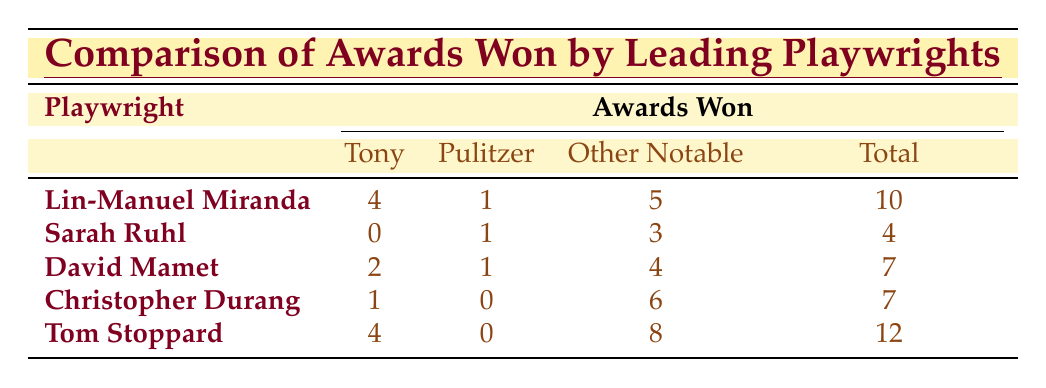What's the total number of awards won by Lin-Manuel Miranda? Lin-Manuel Miranda has won 4 Tony Awards, 1 Pulitzer Prize, and 5 other notable awards. Adding these gives 4 + 1 + 5 = 10 total awards.
Answer: 10 Which playwright has the highest number of total awards? By looking at the total awards column, Tom Stoppard has the highest total awards with 12.
Answer: Tom Stoppard Did Sarah Ruhl win any Tony Awards? According to the table, Sarah Ruhl has won 0 Tony Awards.
Answer: No How many more awards did Tom Stoppard win compared to David Mamet? Tom Stoppard has won 12 awards and David Mamet has won 7. The difference is 12 - 7 = 5.
Answer: 5 What is the average number of Tony Awards won by the playwrights listed? There are 5 playwrights, and their Tony Awards are 4, 0, 2, 1, and 4. Summing these gives 4 + 0 + 2 + 1 + 4 = 11. The average is 11/5 = 2.2.
Answer: 2.2 Which playwright won the most Pulitzer Prizes? Lin-Manuel Miranda, Sarah Ruhl, and David Mamet all won 1 Pulitzer Prize each, while the others did not win any. However, there is no playwright with more than 1 Pulitzer Prize.
Answer: None have more than 1 How many total awards did Christopher Durang and Sarah Ruhl win combined? Christopher Durang has won 7 awards and Sarah Ruhl has won 4. Adding these gives 7 + 4 = 11 total awards combined.
Answer: 11 What percentage of Lin-Manuel Miranda's awards are Tony Awards? Lin-Manuel Miranda has 10 total awards, of which 4 are Tony Awards. The percentage is (4/10) * 100 = 40%.
Answer: 40% Between David Mamet and Christopher Durang, who won more Drama Desk Awards? David Mamet has won 3 Drama Desk Awards, while Christopher Durang has won 2. Thus, David Mamet has won more.
Answer: David Mamet If you consider only the Pulitzer Prizes, how many awards were won by playwrights in total? The playwrights combined have won 1 Pulitzer Prize each for Lin-Manuel Miranda, Sarah Ruhl, and David Mamet, totaling 3 Pulitzer Prizes.
Answer: 3 Which playwright has won the most other notable awards? The total number of other notable awards won by each playwright are Lin-Manuel Miranda - 5, Sarah Ruhl - 3, David Mamet - 4, Christopher Durang - 6, Tom Stoppard - 8. Tom Stoppard won the most with 8 other notable awards.
Answer: Tom Stoppard 